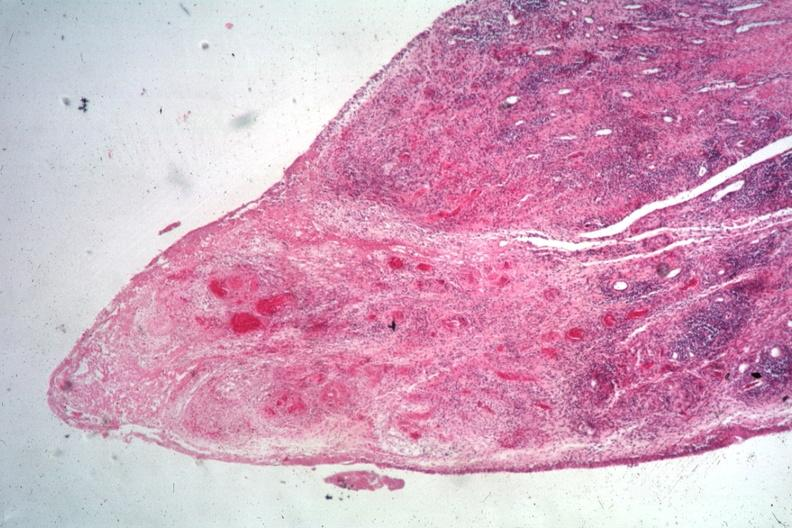does this image show typical lesion case associated with widespread vasculitis?
Answer the question using a single word or phrase. Yes 